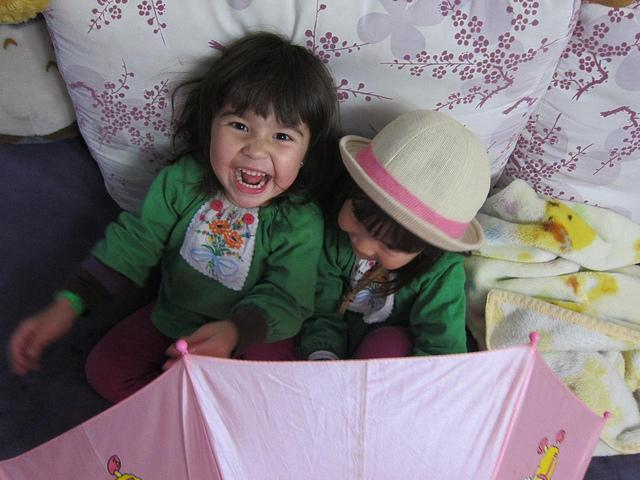What does it look like these girls are?

Choices:
A) different genders
B) different parents
C) twins
D) different races twins 